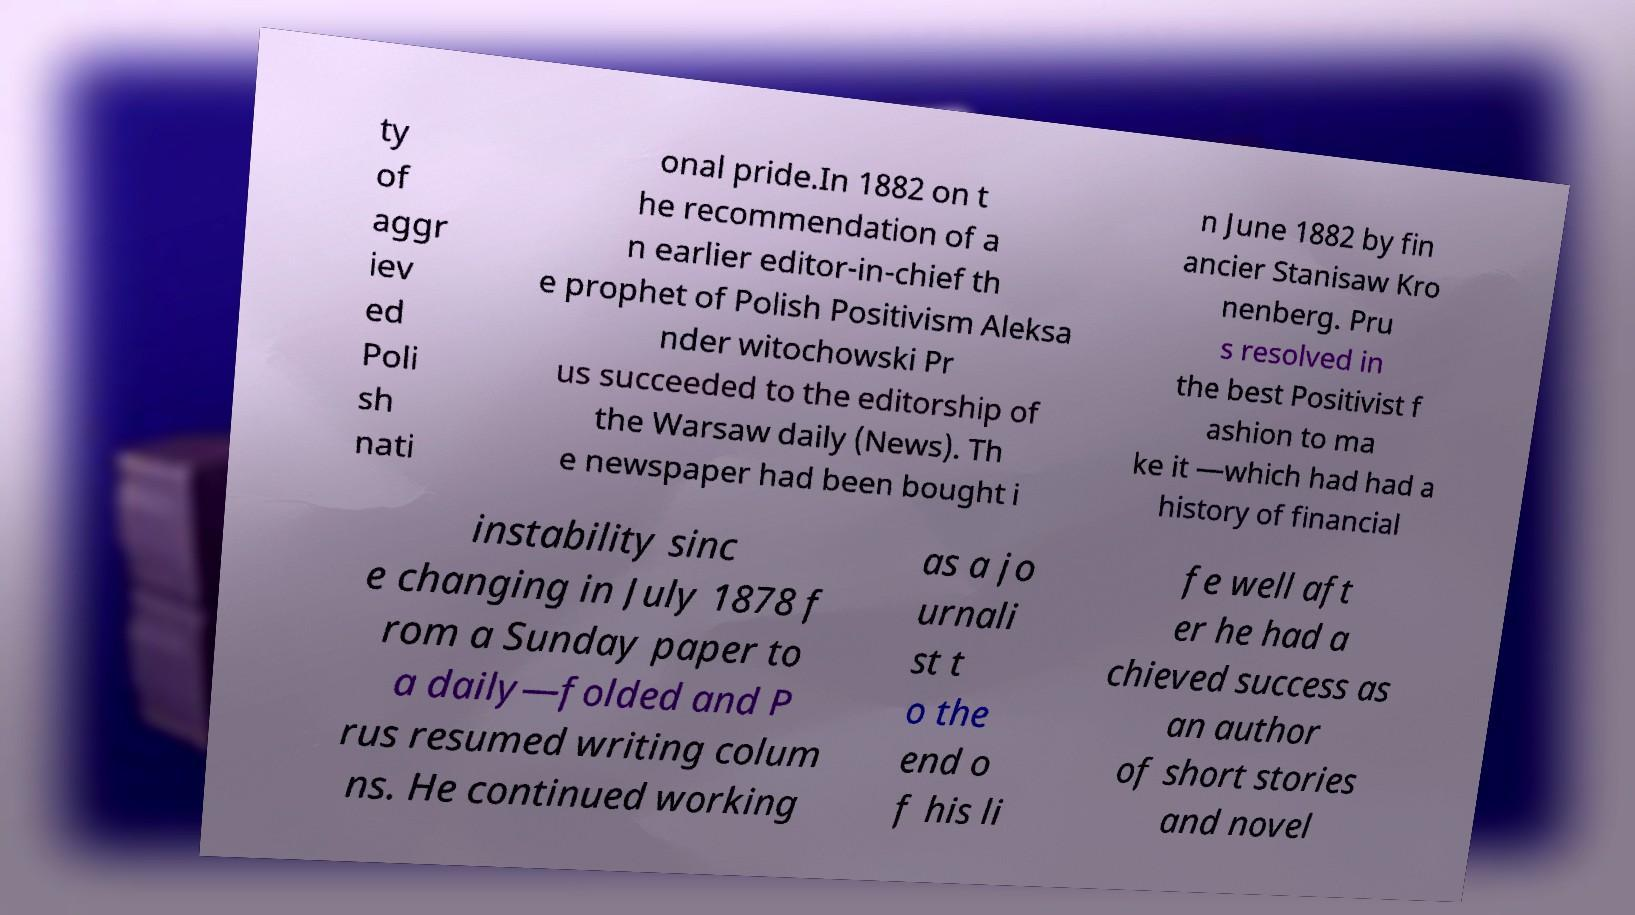Could you extract and type out the text from this image? ty of aggr iev ed Poli sh nati onal pride.In 1882 on t he recommendation of a n earlier editor-in-chief th e prophet of Polish Positivism Aleksa nder witochowski Pr us succeeded to the editorship of the Warsaw daily (News). Th e newspaper had been bought i n June 1882 by fin ancier Stanisaw Kro nenberg. Pru s resolved in the best Positivist f ashion to ma ke it —which had had a history of financial instability sinc e changing in July 1878 f rom a Sunday paper to a daily—folded and P rus resumed writing colum ns. He continued working as a jo urnali st t o the end o f his li fe well aft er he had a chieved success as an author of short stories and novel 